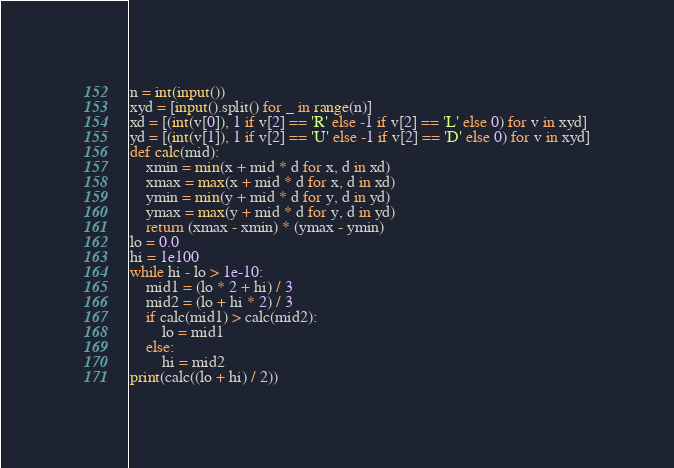<code> <loc_0><loc_0><loc_500><loc_500><_Python_>n = int(input())
xyd = [input().split() for _ in range(n)]
xd = [(int(v[0]), 1 if v[2] == 'R' else -1 if v[2] == 'L' else 0) for v in xyd]
yd = [(int(v[1]), 1 if v[2] == 'U' else -1 if v[2] == 'D' else 0) for v in xyd]
def calc(mid):
    xmin = min(x + mid * d for x, d in xd)
    xmax = max(x + mid * d for x, d in xd)
    ymin = min(y + mid * d for y, d in yd)
    ymax = max(y + mid * d for y, d in yd)
    return (xmax - xmin) * (ymax - ymin)
lo = 0.0
hi = 1e100
while hi - lo > 1e-10:
    mid1 = (lo * 2 + hi) / 3
    mid2 = (lo + hi * 2) / 3
    if calc(mid1) > calc(mid2):
        lo = mid1
    else:
        hi = mid2
print(calc((lo + hi) / 2))
</code> 